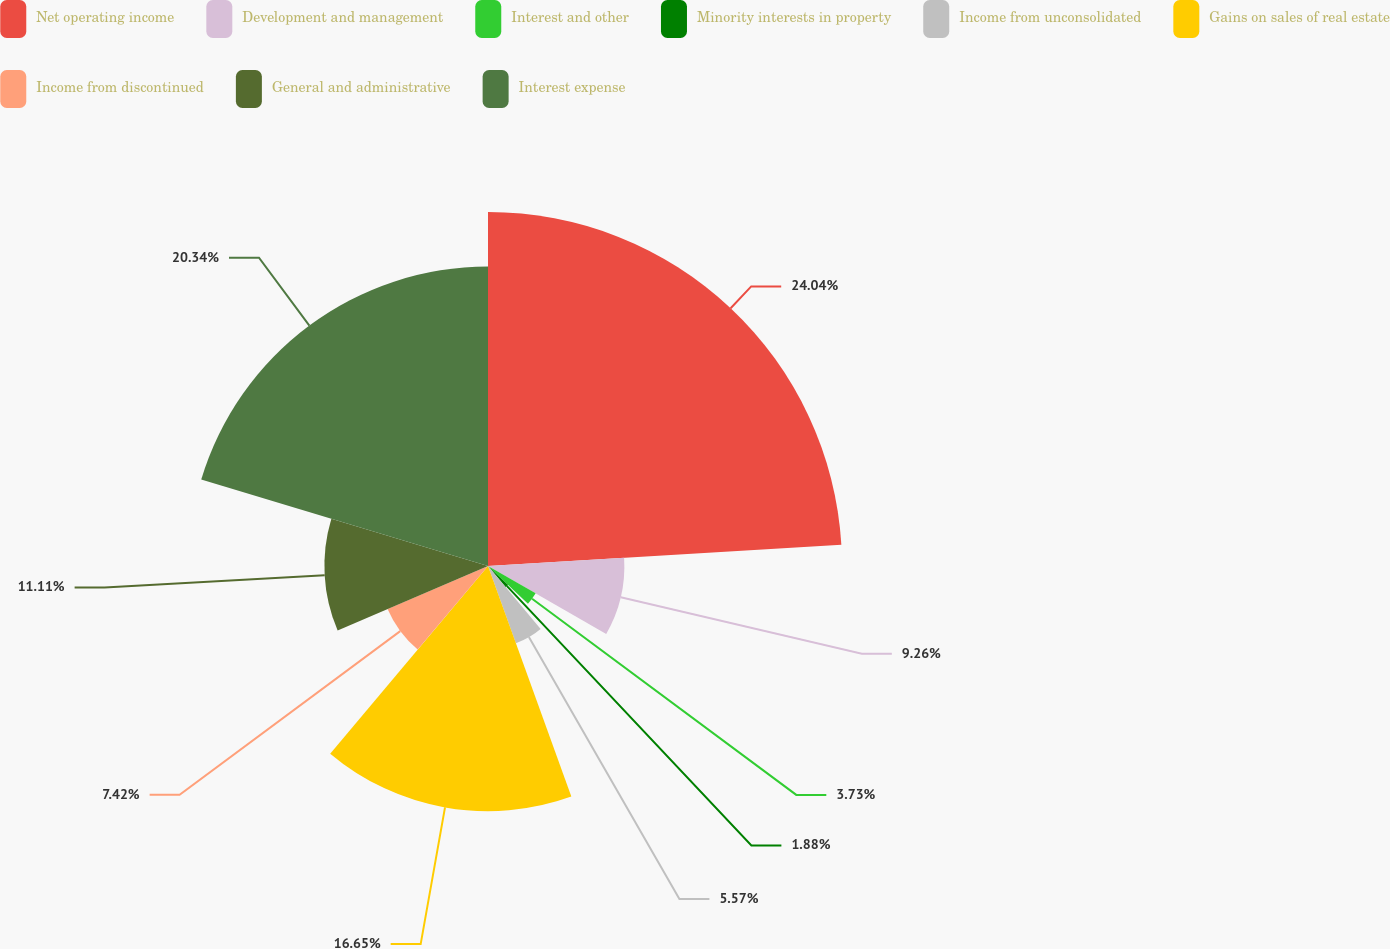Convert chart to OTSL. <chart><loc_0><loc_0><loc_500><loc_500><pie_chart><fcel>Net operating income<fcel>Development and management<fcel>Interest and other<fcel>Minority interests in property<fcel>Income from unconsolidated<fcel>Gains on sales of real estate<fcel>Income from discontinued<fcel>General and administrative<fcel>Interest expense<nl><fcel>24.04%<fcel>9.26%<fcel>3.73%<fcel>1.88%<fcel>5.57%<fcel>16.65%<fcel>7.42%<fcel>11.11%<fcel>20.34%<nl></chart> 